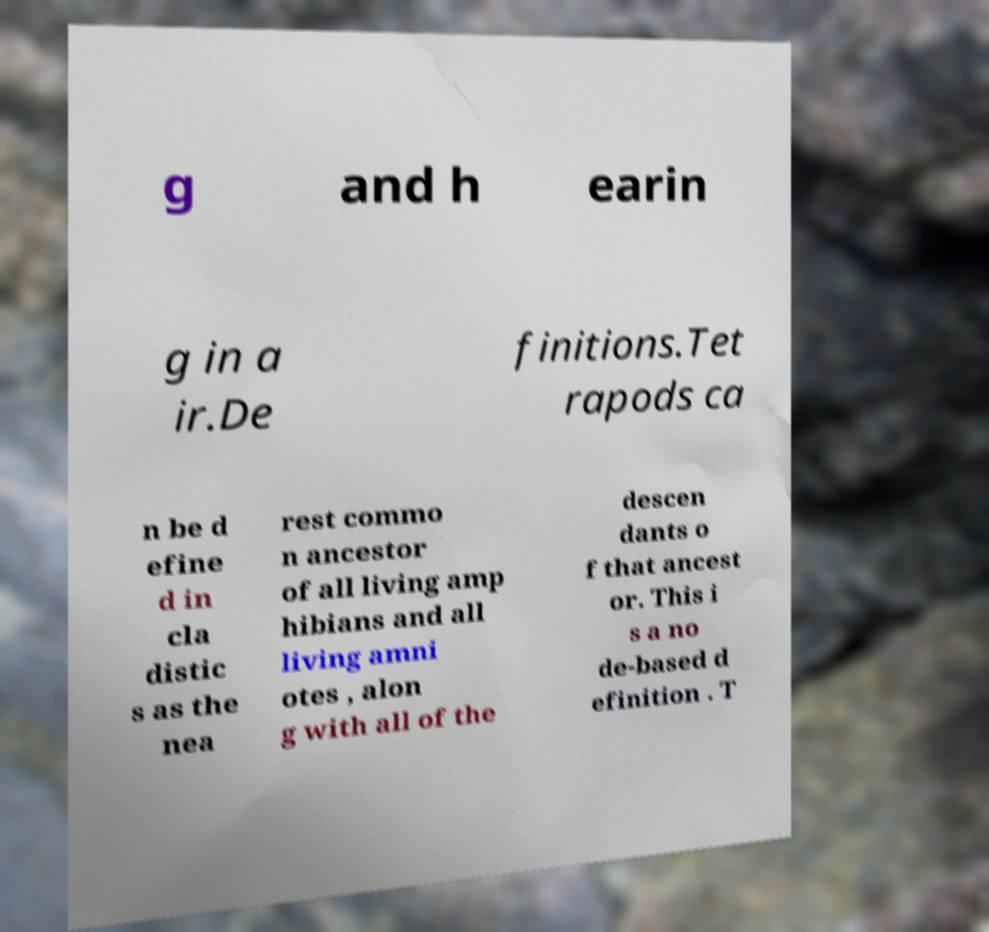Please identify and transcribe the text found in this image. g and h earin g in a ir.De finitions.Tet rapods ca n be d efine d in cla distic s as the nea rest commo n ancestor of all living amp hibians and all living amni otes , alon g with all of the descen dants o f that ancest or. This i s a no de-based d efinition . T 